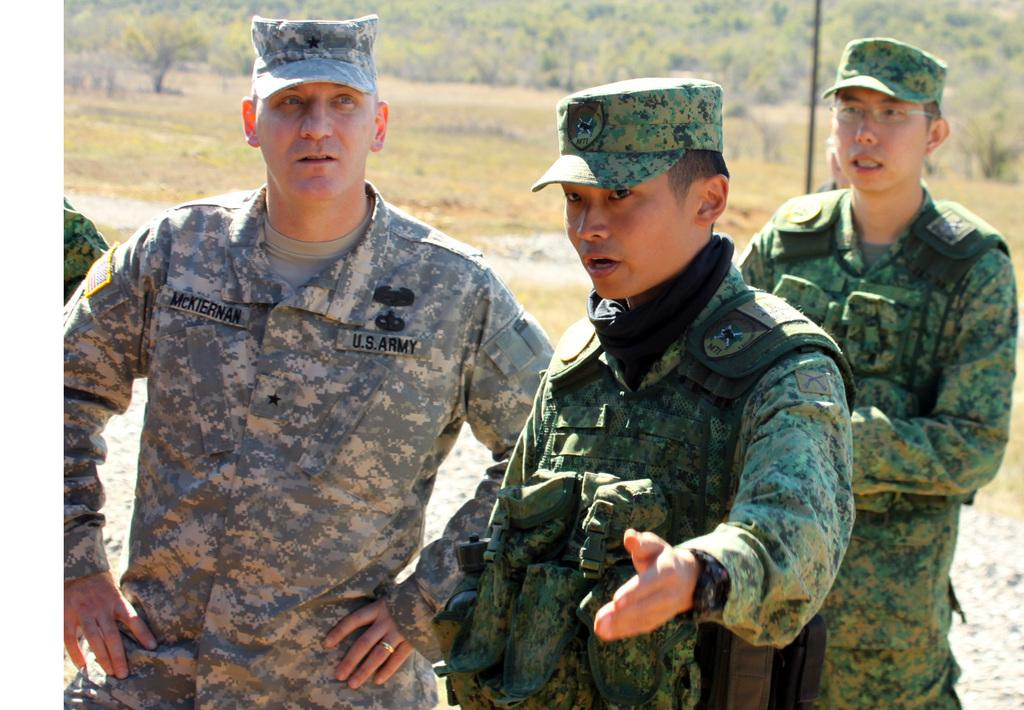How many people are in the image? There are three persons in the image. What are the people wearing? All three persons are wearing army dresses and caps. What can be seen in the background of the image? There are trees and grass on the ground in the background of the image. Can you see a snail crawling on the cap of one of the persons in the image? There is no snail visible in the image. What type of lipstick is the person in the middle wearing in the image? There is no lipstick or indication of makeup on any of the persons in the image. 